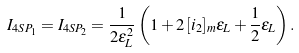<formula> <loc_0><loc_0><loc_500><loc_500>I _ { 4 S P _ { 1 } } = I _ { 4 S P _ { 2 } } = \frac { 1 } { 2 \epsilon _ { L } ^ { 2 } } \left ( 1 + 2 \, [ i _ { 2 } ] _ { m } \epsilon _ { L } + \frac { 1 } { 2 } \epsilon _ { L } \right ) .</formula> 